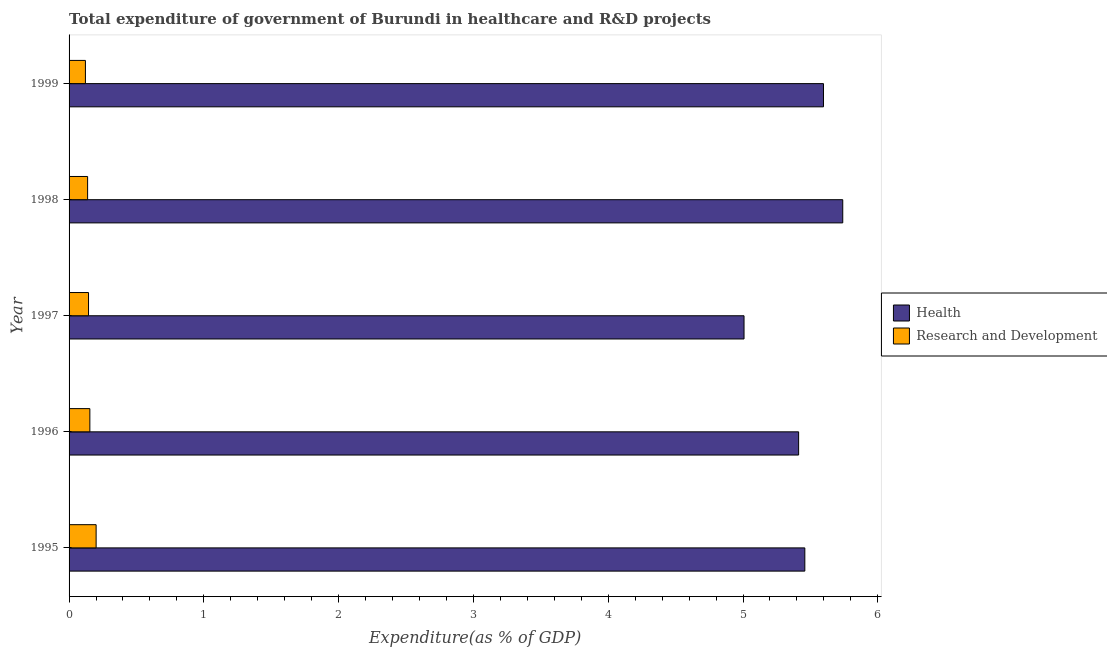How many groups of bars are there?
Ensure brevity in your answer.  5. How many bars are there on the 2nd tick from the bottom?
Give a very brief answer. 2. What is the label of the 1st group of bars from the top?
Ensure brevity in your answer.  1999. What is the expenditure in r&d in 1998?
Keep it short and to the point. 0.14. Across all years, what is the maximum expenditure in healthcare?
Your answer should be very brief. 5.74. Across all years, what is the minimum expenditure in healthcare?
Give a very brief answer. 5.01. In which year was the expenditure in healthcare minimum?
Offer a very short reply. 1997. What is the total expenditure in r&d in the graph?
Offer a terse response. 0.76. What is the difference between the expenditure in healthcare in 1996 and that in 1998?
Keep it short and to the point. -0.33. What is the difference between the expenditure in healthcare in 1997 and the expenditure in r&d in 1996?
Ensure brevity in your answer.  4.85. What is the average expenditure in r&d per year?
Provide a succinct answer. 0.15. In the year 1995, what is the difference between the expenditure in healthcare and expenditure in r&d?
Make the answer very short. 5.26. What is the ratio of the expenditure in healthcare in 1997 to that in 1998?
Provide a succinct answer. 0.87. Is the expenditure in healthcare in 1996 less than that in 1999?
Offer a very short reply. Yes. Is the difference between the expenditure in r&d in 1996 and 1998 greater than the difference between the expenditure in healthcare in 1996 and 1998?
Your answer should be compact. Yes. What is the difference between the highest and the second highest expenditure in r&d?
Keep it short and to the point. 0.05. What is the difference between the highest and the lowest expenditure in r&d?
Keep it short and to the point. 0.08. In how many years, is the expenditure in r&d greater than the average expenditure in r&d taken over all years?
Your answer should be very brief. 2. What does the 2nd bar from the top in 1999 represents?
Your answer should be compact. Health. What does the 2nd bar from the bottom in 1999 represents?
Give a very brief answer. Research and Development. How many bars are there?
Provide a succinct answer. 10. How many years are there in the graph?
Ensure brevity in your answer.  5. What is the difference between two consecutive major ticks on the X-axis?
Keep it short and to the point. 1. Does the graph contain any zero values?
Make the answer very short. No. How many legend labels are there?
Your answer should be very brief. 2. What is the title of the graph?
Offer a very short reply. Total expenditure of government of Burundi in healthcare and R&D projects. What is the label or title of the X-axis?
Your answer should be compact. Expenditure(as % of GDP). What is the Expenditure(as % of GDP) of Health in 1995?
Ensure brevity in your answer.  5.46. What is the Expenditure(as % of GDP) of Research and Development in 1995?
Your answer should be very brief. 0.2. What is the Expenditure(as % of GDP) in Health in 1996?
Ensure brevity in your answer.  5.41. What is the Expenditure(as % of GDP) in Research and Development in 1996?
Offer a very short reply. 0.15. What is the Expenditure(as % of GDP) in Health in 1997?
Keep it short and to the point. 5.01. What is the Expenditure(as % of GDP) of Research and Development in 1997?
Your answer should be compact. 0.14. What is the Expenditure(as % of GDP) of Health in 1998?
Ensure brevity in your answer.  5.74. What is the Expenditure(as % of GDP) in Research and Development in 1998?
Keep it short and to the point. 0.14. What is the Expenditure(as % of GDP) of Health in 1999?
Offer a very short reply. 5.6. What is the Expenditure(as % of GDP) in Research and Development in 1999?
Your answer should be very brief. 0.12. Across all years, what is the maximum Expenditure(as % of GDP) in Health?
Offer a terse response. 5.74. Across all years, what is the maximum Expenditure(as % of GDP) of Research and Development?
Your response must be concise. 0.2. Across all years, what is the minimum Expenditure(as % of GDP) of Health?
Keep it short and to the point. 5.01. Across all years, what is the minimum Expenditure(as % of GDP) in Research and Development?
Your answer should be compact. 0.12. What is the total Expenditure(as % of GDP) of Health in the graph?
Make the answer very short. 27.22. What is the total Expenditure(as % of GDP) of Research and Development in the graph?
Keep it short and to the point. 0.76. What is the difference between the Expenditure(as % of GDP) in Health in 1995 and that in 1996?
Offer a very short reply. 0.05. What is the difference between the Expenditure(as % of GDP) in Research and Development in 1995 and that in 1996?
Keep it short and to the point. 0.05. What is the difference between the Expenditure(as % of GDP) in Health in 1995 and that in 1997?
Your response must be concise. 0.45. What is the difference between the Expenditure(as % of GDP) of Research and Development in 1995 and that in 1997?
Your response must be concise. 0.06. What is the difference between the Expenditure(as % of GDP) in Health in 1995 and that in 1998?
Make the answer very short. -0.28. What is the difference between the Expenditure(as % of GDP) of Research and Development in 1995 and that in 1998?
Your answer should be very brief. 0.06. What is the difference between the Expenditure(as % of GDP) of Health in 1995 and that in 1999?
Make the answer very short. -0.14. What is the difference between the Expenditure(as % of GDP) of Research and Development in 1995 and that in 1999?
Make the answer very short. 0.08. What is the difference between the Expenditure(as % of GDP) of Health in 1996 and that in 1997?
Your answer should be compact. 0.41. What is the difference between the Expenditure(as % of GDP) of Research and Development in 1996 and that in 1997?
Give a very brief answer. 0.01. What is the difference between the Expenditure(as % of GDP) in Health in 1996 and that in 1998?
Provide a short and direct response. -0.33. What is the difference between the Expenditure(as % of GDP) of Research and Development in 1996 and that in 1998?
Give a very brief answer. 0.02. What is the difference between the Expenditure(as % of GDP) of Health in 1996 and that in 1999?
Make the answer very short. -0.18. What is the difference between the Expenditure(as % of GDP) of Research and Development in 1996 and that in 1999?
Your response must be concise. 0.03. What is the difference between the Expenditure(as % of GDP) of Health in 1997 and that in 1998?
Provide a succinct answer. -0.73. What is the difference between the Expenditure(as % of GDP) of Research and Development in 1997 and that in 1998?
Provide a short and direct response. 0.01. What is the difference between the Expenditure(as % of GDP) of Health in 1997 and that in 1999?
Give a very brief answer. -0.59. What is the difference between the Expenditure(as % of GDP) in Research and Development in 1997 and that in 1999?
Make the answer very short. 0.02. What is the difference between the Expenditure(as % of GDP) in Health in 1998 and that in 1999?
Provide a short and direct response. 0.14. What is the difference between the Expenditure(as % of GDP) of Research and Development in 1998 and that in 1999?
Offer a very short reply. 0.02. What is the difference between the Expenditure(as % of GDP) of Health in 1995 and the Expenditure(as % of GDP) of Research and Development in 1996?
Ensure brevity in your answer.  5.3. What is the difference between the Expenditure(as % of GDP) in Health in 1995 and the Expenditure(as % of GDP) in Research and Development in 1997?
Your response must be concise. 5.31. What is the difference between the Expenditure(as % of GDP) in Health in 1995 and the Expenditure(as % of GDP) in Research and Development in 1998?
Give a very brief answer. 5.32. What is the difference between the Expenditure(as % of GDP) of Health in 1995 and the Expenditure(as % of GDP) of Research and Development in 1999?
Give a very brief answer. 5.34. What is the difference between the Expenditure(as % of GDP) in Health in 1996 and the Expenditure(as % of GDP) in Research and Development in 1997?
Ensure brevity in your answer.  5.27. What is the difference between the Expenditure(as % of GDP) in Health in 1996 and the Expenditure(as % of GDP) in Research and Development in 1998?
Ensure brevity in your answer.  5.28. What is the difference between the Expenditure(as % of GDP) in Health in 1996 and the Expenditure(as % of GDP) in Research and Development in 1999?
Your answer should be very brief. 5.29. What is the difference between the Expenditure(as % of GDP) in Health in 1997 and the Expenditure(as % of GDP) in Research and Development in 1998?
Your answer should be compact. 4.87. What is the difference between the Expenditure(as % of GDP) in Health in 1997 and the Expenditure(as % of GDP) in Research and Development in 1999?
Your response must be concise. 4.89. What is the difference between the Expenditure(as % of GDP) in Health in 1998 and the Expenditure(as % of GDP) in Research and Development in 1999?
Offer a terse response. 5.62. What is the average Expenditure(as % of GDP) of Health per year?
Provide a short and direct response. 5.44. What is the average Expenditure(as % of GDP) of Research and Development per year?
Your response must be concise. 0.15. In the year 1995, what is the difference between the Expenditure(as % of GDP) in Health and Expenditure(as % of GDP) in Research and Development?
Ensure brevity in your answer.  5.26. In the year 1996, what is the difference between the Expenditure(as % of GDP) in Health and Expenditure(as % of GDP) in Research and Development?
Your answer should be very brief. 5.26. In the year 1997, what is the difference between the Expenditure(as % of GDP) of Health and Expenditure(as % of GDP) of Research and Development?
Give a very brief answer. 4.86. In the year 1998, what is the difference between the Expenditure(as % of GDP) of Health and Expenditure(as % of GDP) of Research and Development?
Ensure brevity in your answer.  5.6. In the year 1999, what is the difference between the Expenditure(as % of GDP) in Health and Expenditure(as % of GDP) in Research and Development?
Make the answer very short. 5.48. What is the ratio of the Expenditure(as % of GDP) in Health in 1995 to that in 1996?
Offer a very short reply. 1.01. What is the ratio of the Expenditure(as % of GDP) of Research and Development in 1995 to that in 1996?
Provide a short and direct response. 1.3. What is the ratio of the Expenditure(as % of GDP) in Health in 1995 to that in 1997?
Your response must be concise. 1.09. What is the ratio of the Expenditure(as % of GDP) of Research and Development in 1995 to that in 1997?
Your response must be concise. 1.39. What is the ratio of the Expenditure(as % of GDP) of Health in 1995 to that in 1998?
Offer a very short reply. 0.95. What is the ratio of the Expenditure(as % of GDP) of Research and Development in 1995 to that in 1998?
Offer a terse response. 1.46. What is the ratio of the Expenditure(as % of GDP) of Health in 1995 to that in 1999?
Your response must be concise. 0.98. What is the ratio of the Expenditure(as % of GDP) in Research and Development in 1995 to that in 1999?
Ensure brevity in your answer.  1.66. What is the ratio of the Expenditure(as % of GDP) of Health in 1996 to that in 1997?
Provide a succinct answer. 1.08. What is the ratio of the Expenditure(as % of GDP) of Research and Development in 1996 to that in 1997?
Offer a very short reply. 1.07. What is the ratio of the Expenditure(as % of GDP) of Health in 1996 to that in 1998?
Provide a succinct answer. 0.94. What is the ratio of the Expenditure(as % of GDP) in Research and Development in 1996 to that in 1998?
Ensure brevity in your answer.  1.12. What is the ratio of the Expenditure(as % of GDP) of Health in 1996 to that in 1999?
Your answer should be very brief. 0.97. What is the ratio of the Expenditure(as % of GDP) in Research and Development in 1996 to that in 1999?
Keep it short and to the point. 1.27. What is the ratio of the Expenditure(as % of GDP) in Health in 1997 to that in 1998?
Keep it short and to the point. 0.87. What is the ratio of the Expenditure(as % of GDP) in Research and Development in 1997 to that in 1998?
Provide a succinct answer. 1.05. What is the ratio of the Expenditure(as % of GDP) in Health in 1997 to that in 1999?
Provide a succinct answer. 0.89. What is the ratio of the Expenditure(as % of GDP) of Research and Development in 1997 to that in 1999?
Your answer should be very brief. 1.19. What is the ratio of the Expenditure(as % of GDP) of Health in 1998 to that in 1999?
Your answer should be compact. 1.03. What is the ratio of the Expenditure(as % of GDP) of Research and Development in 1998 to that in 1999?
Ensure brevity in your answer.  1.13. What is the difference between the highest and the second highest Expenditure(as % of GDP) in Health?
Make the answer very short. 0.14. What is the difference between the highest and the second highest Expenditure(as % of GDP) of Research and Development?
Your answer should be compact. 0.05. What is the difference between the highest and the lowest Expenditure(as % of GDP) of Health?
Your response must be concise. 0.73. What is the difference between the highest and the lowest Expenditure(as % of GDP) of Research and Development?
Give a very brief answer. 0.08. 